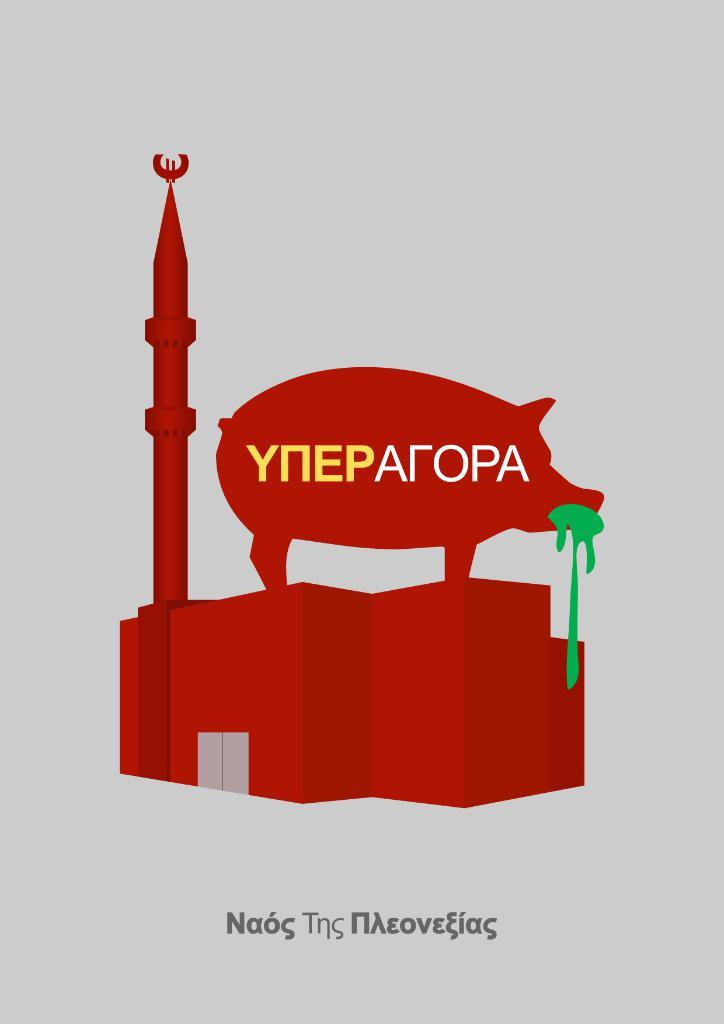Provide a one-sentence caption for the provided image. A poster with a pig on it that says YNEPALOPA. 